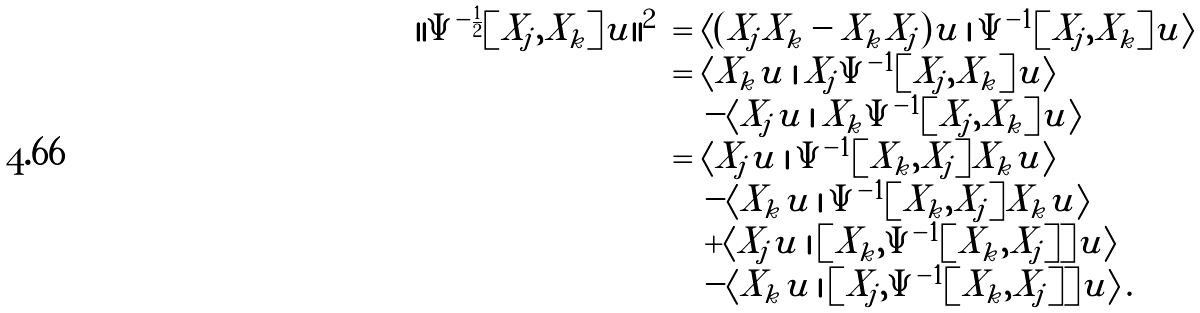Convert formula to latex. <formula><loc_0><loc_0><loc_500><loc_500>\begin{array} { l l } | | \Psi ^ { - \frac { 1 } { 2 } } [ X _ { j } , X _ { k } ] u | | ^ { 2 } & = \langle ( X _ { j } X _ { k } - X _ { k } X _ { j } ) u \, | \, \Psi ^ { - 1 } [ X _ { j } , X _ { k } ] u \rangle \\ & = \langle X _ { k } u \, | \, X _ { j } \Psi ^ { - 1 } [ X _ { j } , X _ { k } ] u \rangle \\ & \quad - \langle X _ { j } u \, | \, X _ { k } \Psi ^ { - 1 } [ X _ { j } , X _ { k } ] u \rangle \\ & = \langle X _ { j } u \, | \, \Psi ^ { - 1 } [ X _ { k } , X _ { j } ] X _ { k } u \rangle \\ & \quad - \langle X _ { k } u \, | \, \Psi ^ { - 1 } [ X _ { k } , X _ { j } ] X _ { k } u \rangle \\ & \quad + \langle X _ { j } u \, | \, [ X _ { k } , \Psi ^ { - 1 } [ X _ { k } , X _ { j } ] ] u \rangle \\ & \quad - \langle X _ { k } u \, | \, [ X _ { j } , \Psi ^ { - 1 } [ X _ { k } , X _ { j } ] ] u \rangle \, . \end{array}</formula> 